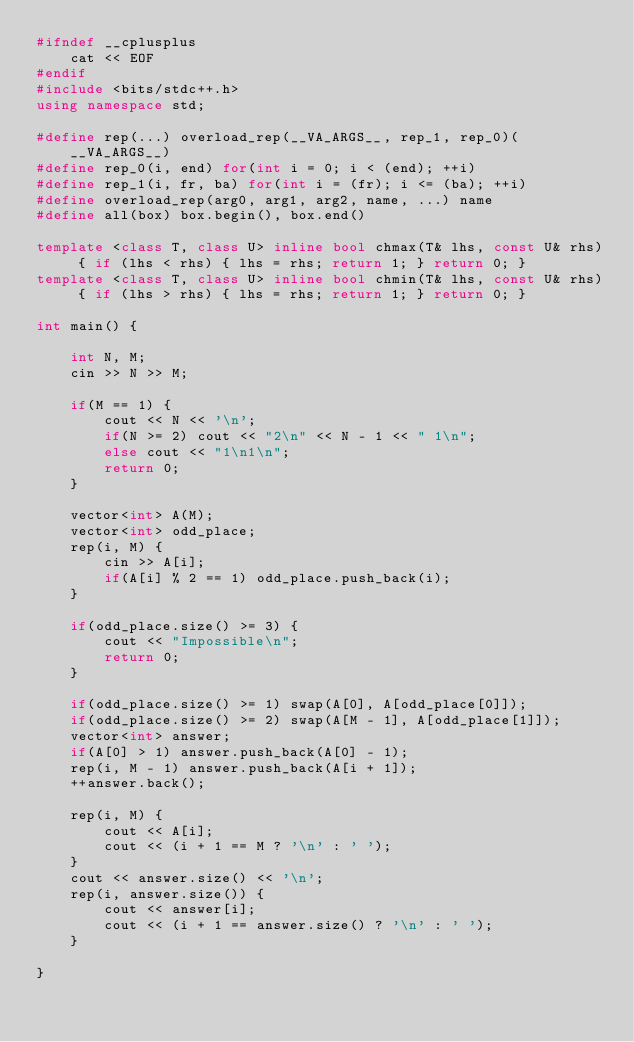<code> <loc_0><loc_0><loc_500><loc_500><_C++_>#ifndef __cplusplus
    cat << EOF
#endif
#include <bits/stdc++.h>
using namespace std;

#define rep(...) overload_rep(__VA_ARGS__, rep_1, rep_0)(__VA_ARGS__)
#define rep_0(i, end) for(int i = 0; i < (end); ++i)
#define rep_1(i, fr, ba) for(int i = (fr); i <= (ba); ++i)
#define overload_rep(arg0, arg1, arg2, name, ...) name
#define all(box) box.begin(), box.end()

template <class T, class U> inline bool chmax(T& lhs, const U& rhs) { if (lhs < rhs) { lhs = rhs; return 1; } return 0; }
template <class T, class U> inline bool chmin(T& lhs, const U& rhs) { if (lhs > rhs) { lhs = rhs; return 1; } return 0; }

int main() {

    int N, M;
    cin >> N >> M;

    if(M == 1) {
        cout << N << '\n';
        if(N >= 2) cout << "2\n" << N - 1 << " 1\n";
        else cout << "1\n1\n";
        return 0;
    }

    vector<int> A(M);
    vector<int> odd_place;
    rep(i, M) {
        cin >> A[i];
        if(A[i] % 2 == 1) odd_place.push_back(i);
    }

    if(odd_place.size() >= 3) {
        cout << "Impossible\n";
        return 0;
    }

    if(odd_place.size() >= 1) swap(A[0], A[odd_place[0]]);
    if(odd_place.size() >= 2) swap(A[M - 1], A[odd_place[1]]);
    vector<int> answer;
    if(A[0] > 1) answer.push_back(A[0] - 1);
    rep(i, M - 1) answer.push_back(A[i + 1]);
    ++answer.back();

    rep(i, M) {
        cout << A[i];
        cout << (i + 1 == M ? '\n' : ' ');
    }
    cout << answer.size() << '\n';
    rep(i, answer.size()) {
        cout << answer[i];
        cout << (i + 1 == answer.size() ? '\n' : ' ');
    }

}
</code> 